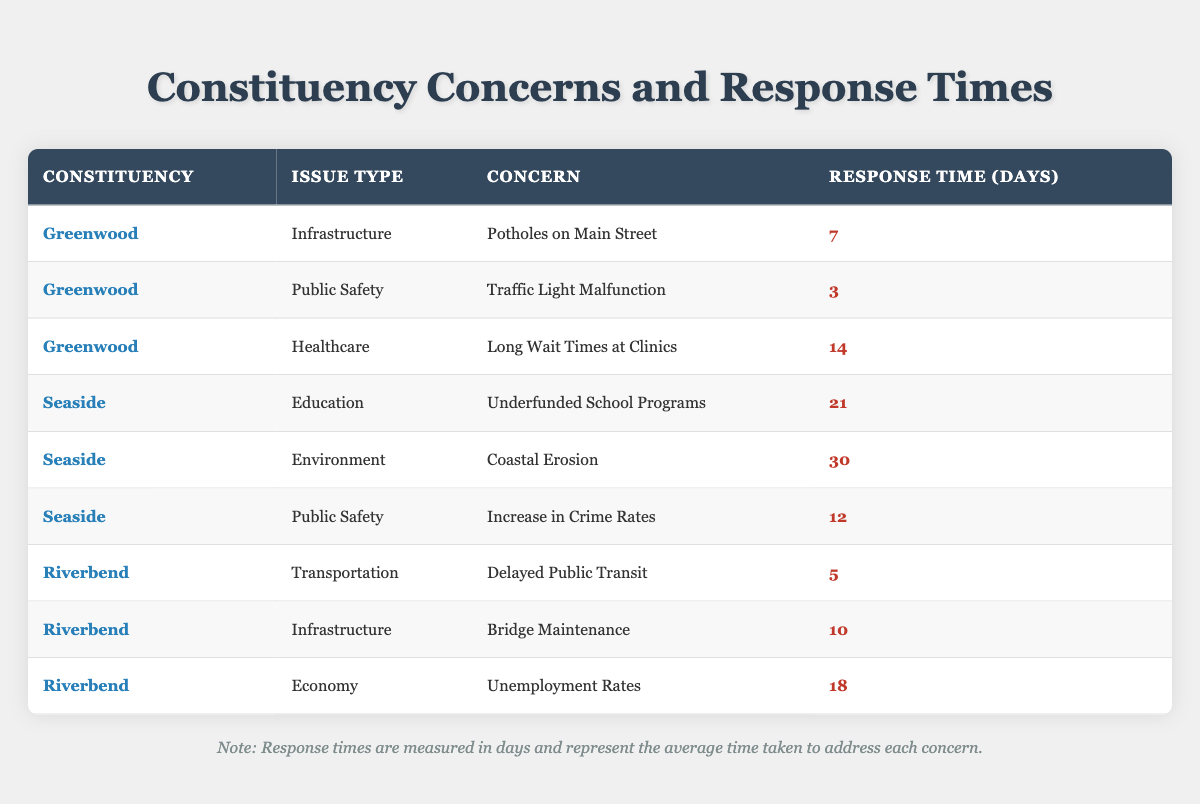What is the response time for the concern "Traffic Light Malfunction" in Greenwood? The table shows that for the issue type "Public Safety" in the constituency "Greenwood", the response time for the concern "Traffic Light Malfunction" is listed as 3 days.
Answer: 3 days What is the longest response time recorded in Seaside? In the table, the entry for "Coastal Erosion" under the issue type "Environment" has the longest response time listed in Seaside, which is 30 days.
Answer: 30 days Which constituency has a concern related to "Unemployment Rates"? The entry for "Unemployment Rates" falls under the issue type "Economy" in the constituency "Riverbend," as indicated in the table.
Answer: Riverbend Is the response time for "Potholes on Main Street" longer than that for "Delayed Public Transit"? The response time for "Potholes on Main Street" in Greenwood is 7 days, while "Delayed Public Transit" in Riverbend is 5 days, so yes, 7 days is greater than 5 days.
Answer: Yes What is the average response time for issues in Riverbend? Within Riverbend, there are three entries with response times of 5 days, 10 days, and 18 days. The sum is 5 + 10 + 18 = 33 days, and dividing by 3 gives an average of 33/3 = 11 days.
Answer: 11 days In which issue type does Greenwood have the shortest response time? The shortest response time for Greenwood is related to the issue type "Public Safety," specifically for the concern "Traffic Light Malfunction," which has a response time of 3 days.
Answer: Public Safety Which constituency has a longer average response time, Seaside or Riverbend? To assess this, calculate the average for Seaside (21 + 30 + 12 = 63 days; 63/3 = 21 days) and Riverbend (5 + 10 + 18 = 33 days; 33/3 = 11 days). Seaside's average is 21 days, which is longer than Riverbend's 11 days.
Answer: Seaside What response time is associated with the concern "Long Wait Times at Clinics"? Looking at the table, the concern "Long Wait Times at Clinics" under the issue type "Healthcare" in Greenwood shows a response time of 14 days.
Answer: 14 days Does Seaside have any concerns with a response time lower than 10 days? The table's entries for Seaside indicate response times of 21 days for "Underfunded School Programs", 30 days for "Coastal Erosion", and 12 days for "Increase in Crime Rates". Thus, all are above 10 days.
Answer: No 